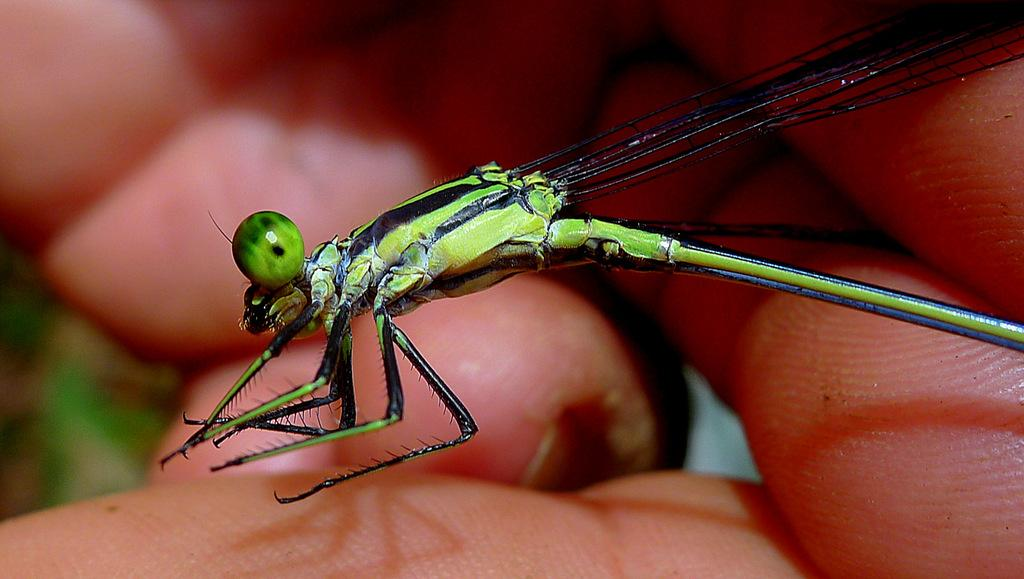What part of a person can be seen in the image? There is a person's hand in the image. What type of creature is present in the image? There is a butterfly in the image. Can you determine the time of day when the image was taken? The image was taken during the day. Can you tell me how the frog is helping the person in the image? There is no frog present in the image, so it cannot be helping the person. What color is the balloon that the person is holding in the image? There is no balloon present in the image, so its color cannot be determined. 